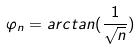<formula> <loc_0><loc_0><loc_500><loc_500>\varphi _ { n } = a r c t a n ( \frac { 1 } { \sqrt { n } } )</formula> 